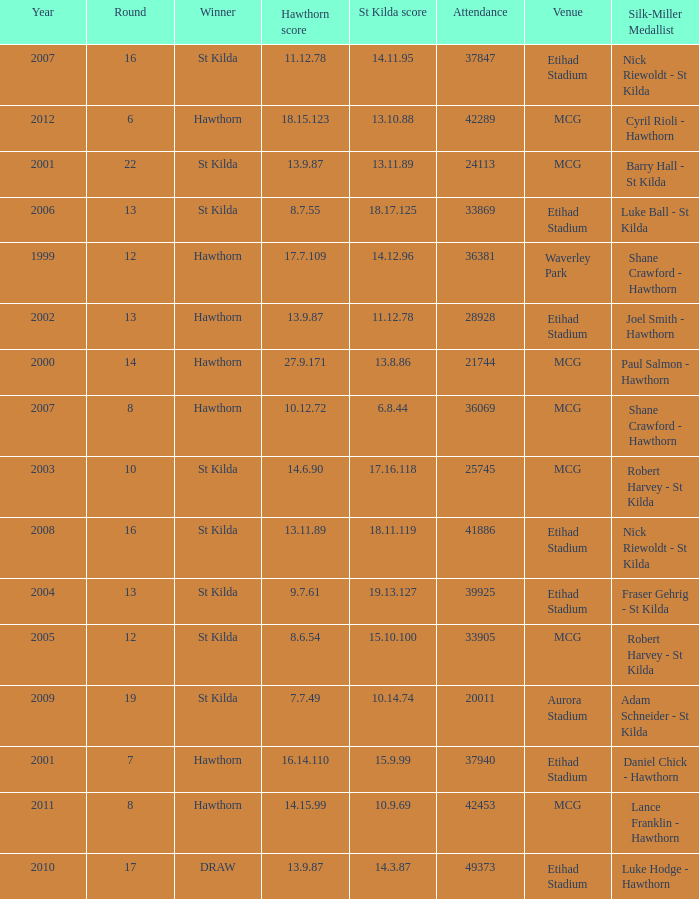How many winners have st kilda score at 14.11.95? 1.0. 